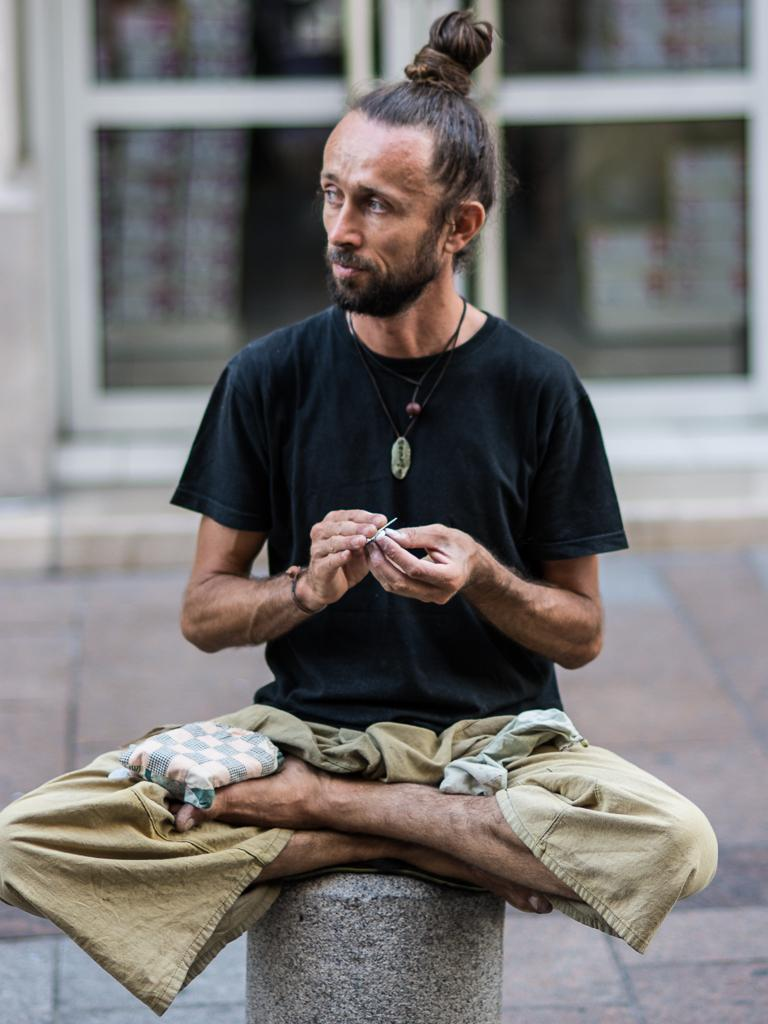Who is present in the image? There is a man in the image. What is the man doing in the image? The man is sitting on a cement pillar. What arithmetic problem is the man solving in the image? There is no arithmetic problem visible in the image, as it only shows a man sitting on a cement pillar. 